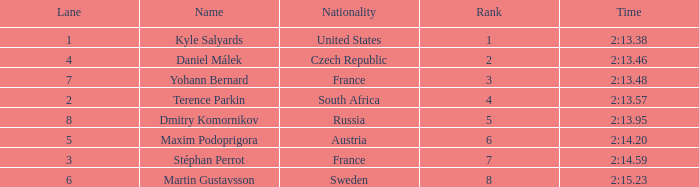What was Stéphan Perrot rank average? 7.0. 